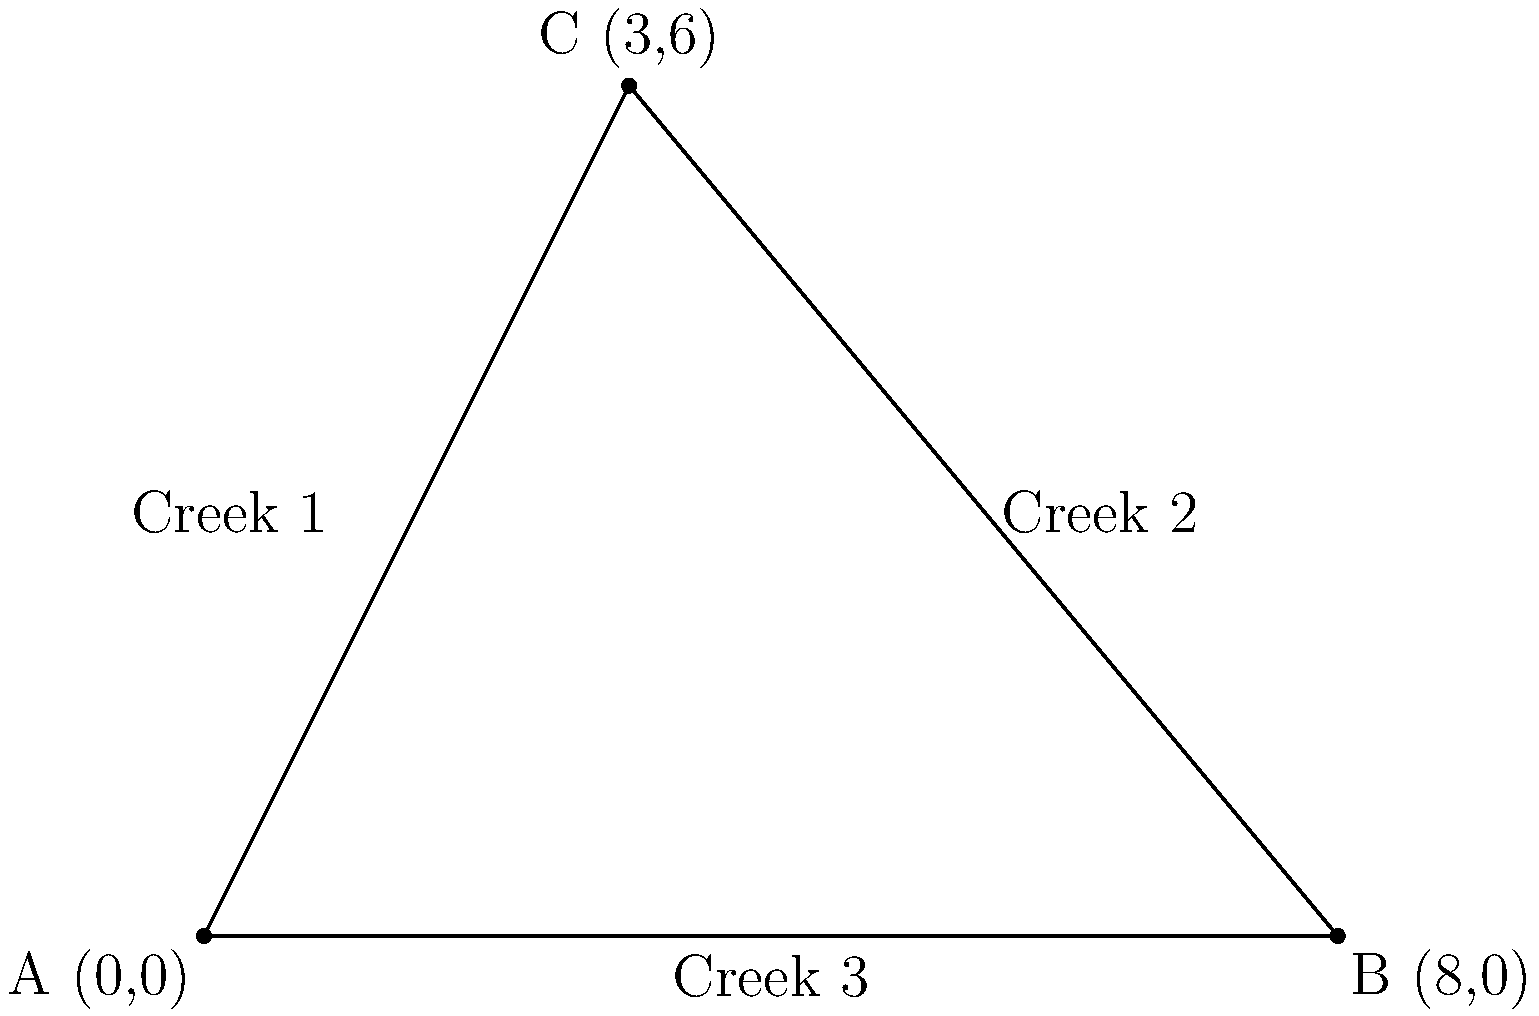During your creek hiking adventure in Nebraska, you come across three confluence points where creeks meet. On your map, these points form a triangle. The coordinates of these points are A(0,0), B(8,0), and C(3,6). Calculate the area of the triangular region formed by these three confluence points. To calculate the area of the triangular region, we can use the formula for the area of a triangle given the coordinates of its vertices:

Area = $\frac{1}{2}|x_1(y_2 - y_3) + x_2(y_3 - y_1) + x_3(y_1 - y_2)|$

Where $(x_1, y_1)$, $(x_2, y_2)$, and $(x_3, y_3)$ are the coordinates of the three vertices.

Given:
A(0,0), B(8,0), C(3,6)

Step 1: Substitute the coordinates into the formula:
Area = $\frac{1}{2}|0(0 - 6) + 8(6 - 0) + 3(0 - 0)|$

Step 2: Simplify the expressions inside the parentheses:
Area = $\frac{1}{2}|0(-6) + 8(6) + 3(0)|$

Step 3: Multiply the terms:
Area = $\frac{1}{2}|0 + 48 + 0|$

Step 4: Add the terms inside the absolute value signs:
Area = $\frac{1}{2}|48|$

Step 5: Calculate the final result:
Area = $\frac{1}{2} \times 48 = 24$

Therefore, the area of the triangular region formed by the three confluence points is 24 square units (based on the scale of your map).
Answer: 24 square units 